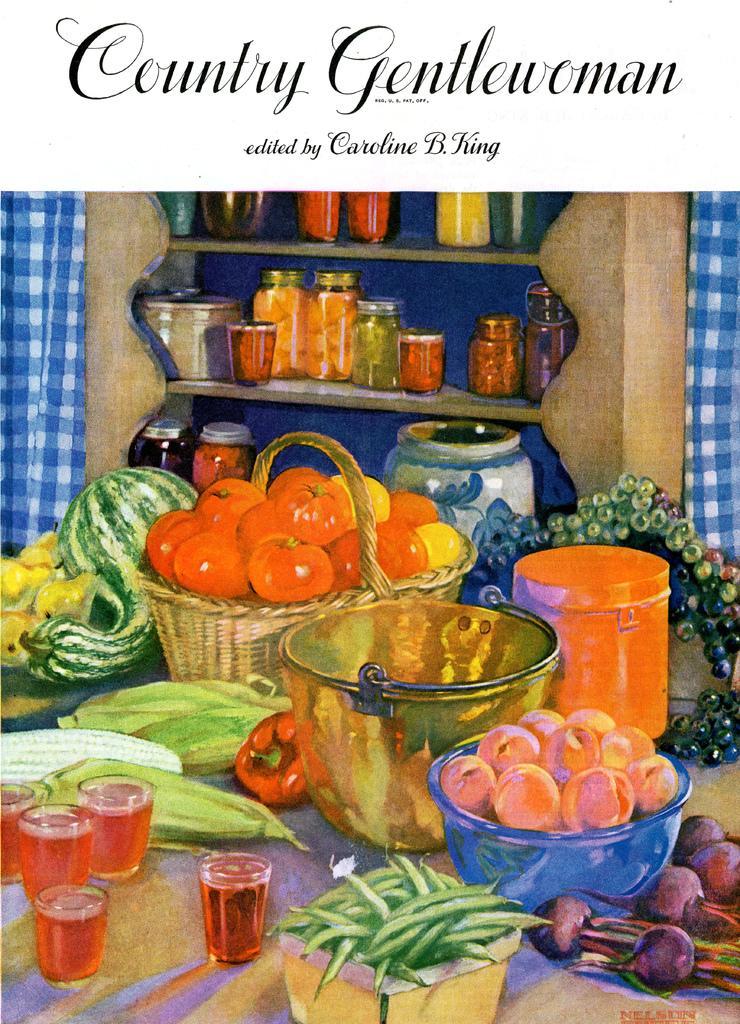Could you give a brief overview of what you see in this image? This image is a poster in which there are vegetables and other fruits on the table. At the top of the image there is some text. 